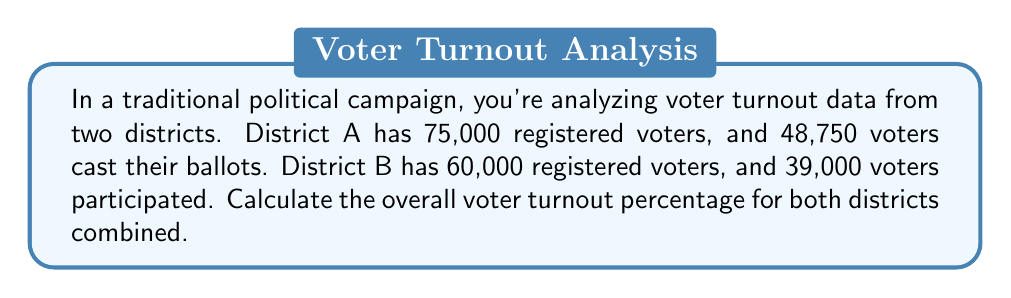Give your solution to this math problem. To solve this problem, we'll follow these steps:

1. Calculate the total number of registered voters:
   $$ \text{Total registered} = 75,000 + 60,000 = 135,000 $$

2. Calculate the total number of voters who cast ballots:
   $$ \text{Total voted} = 48,750 + 39,000 = 87,750 $$

3. Calculate the overall voter turnout percentage:
   $$ \text{Turnout percentage} = \frac{\text{Total voted}}{\text{Total registered}} \times 100\% $$
   
   $$ \text{Turnout percentage} = \frac{87,750}{135,000} \times 100\% $$
   
   $$ \text{Turnout percentage} = 0.65 \times 100\% = 65\% $$

Thus, the overall voter turnout percentage for both districts combined is 65%.
Answer: 65% 